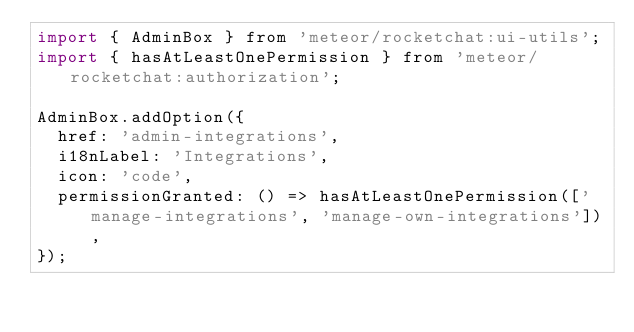<code> <loc_0><loc_0><loc_500><loc_500><_JavaScript_>import { AdminBox } from 'meteor/rocketchat:ui-utils';
import { hasAtLeastOnePermission } from 'meteor/rocketchat:authorization';

AdminBox.addOption({
	href: 'admin-integrations',
	i18nLabel: 'Integrations',
	icon: 'code',
	permissionGranted: () => hasAtLeastOnePermission(['manage-integrations', 'manage-own-integrations']),
});
</code> 